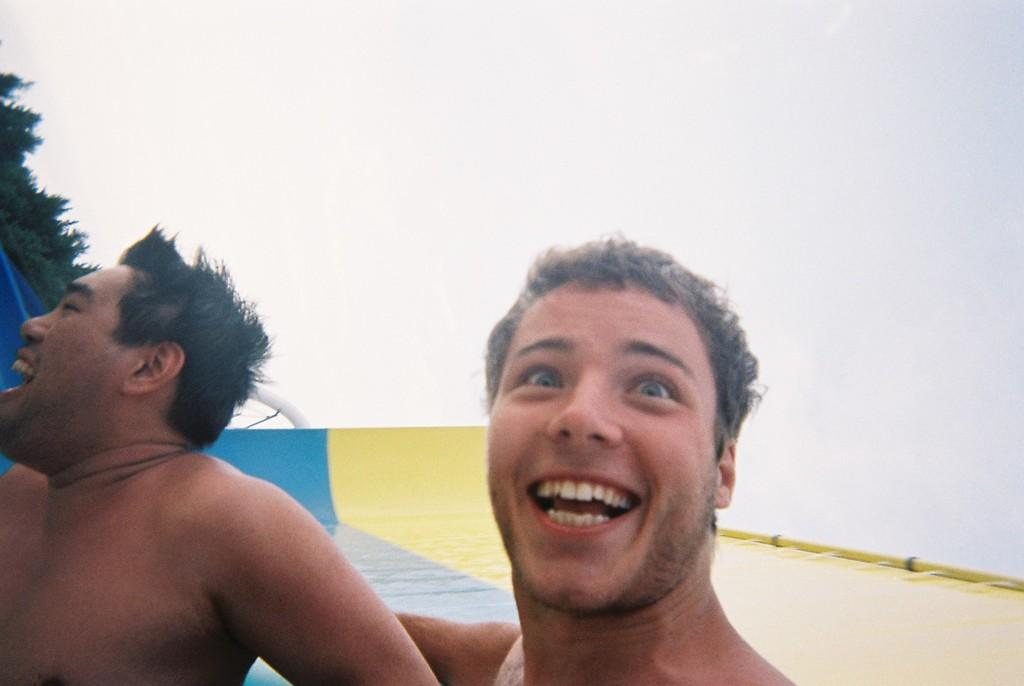How many people are in the image? There are two men in the image. What is the facial expression of the men in the image? The men are smiling. What can be seen in the background of the image? There is sky visible in the background of the image. What is located on the left side of the image? There is a tree on the left side of the image. What type of eggs can be seen in the image? There are no eggs present in the image. Are the two men in the image brothers? The provided facts do not mention any familial relationship between the two men, so we cannot determine if they are brothers. 